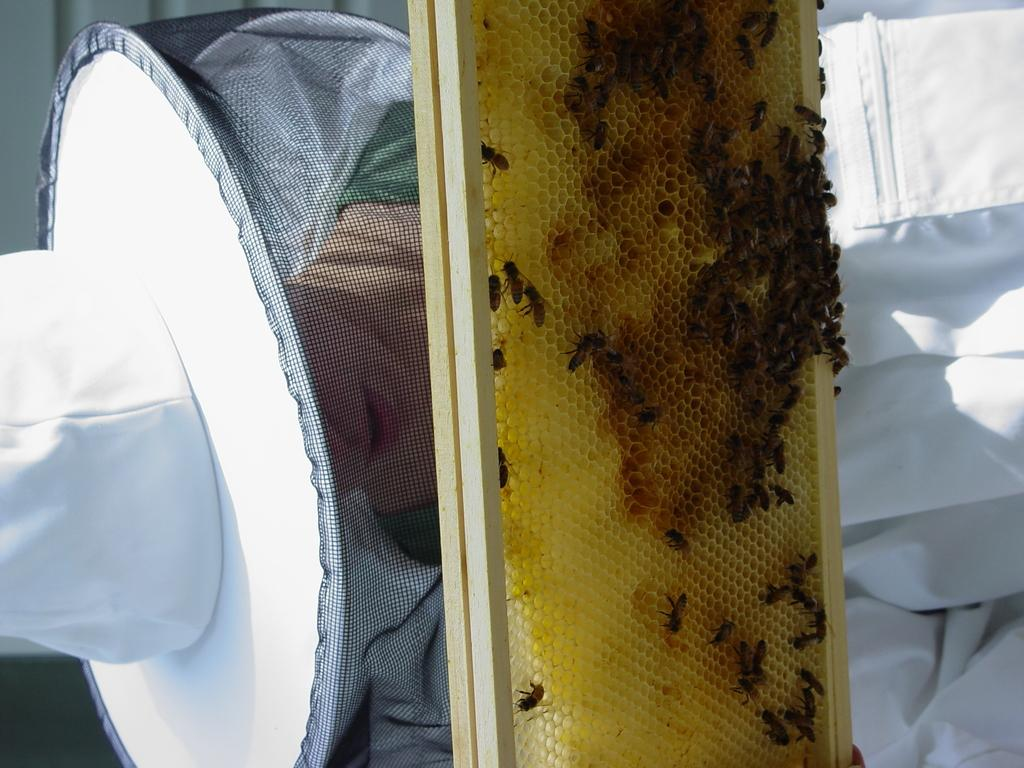Who or what is present in the image? There is a person in the image. What is the person wearing on their head? The person is wearing a hat. What can be seen besides the person in the image? There are honey bees on a honeycomb in the image. What type of root is being used by the queen in the image? There is no queen or root present in the image; it features a person wearing a hat and honey bees on a honeycomb. 